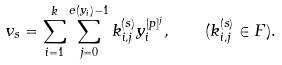Convert formula to latex. <formula><loc_0><loc_0><loc_500><loc_500>v _ { s } = \sum _ { i = 1 } ^ { k } \sum _ { j = 0 } ^ { e ( y _ { i } ) - 1 } k _ { i , j } ^ { ( s ) } y _ { i } ^ { [ p ] ^ { j } } , \quad ( k _ { i , j } ^ { ( s ) } \in F ) .</formula> 